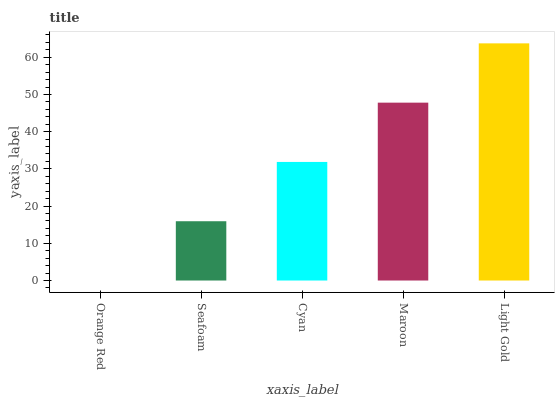Is Orange Red the minimum?
Answer yes or no. Yes. Is Light Gold the maximum?
Answer yes or no. Yes. Is Seafoam the minimum?
Answer yes or no. No. Is Seafoam the maximum?
Answer yes or no. No. Is Seafoam greater than Orange Red?
Answer yes or no. Yes. Is Orange Red less than Seafoam?
Answer yes or no. Yes. Is Orange Red greater than Seafoam?
Answer yes or no. No. Is Seafoam less than Orange Red?
Answer yes or no. No. Is Cyan the high median?
Answer yes or no. Yes. Is Cyan the low median?
Answer yes or no. Yes. Is Seafoam the high median?
Answer yes or no. No. Is Maroon the low median?
Answer yes or no. No. 